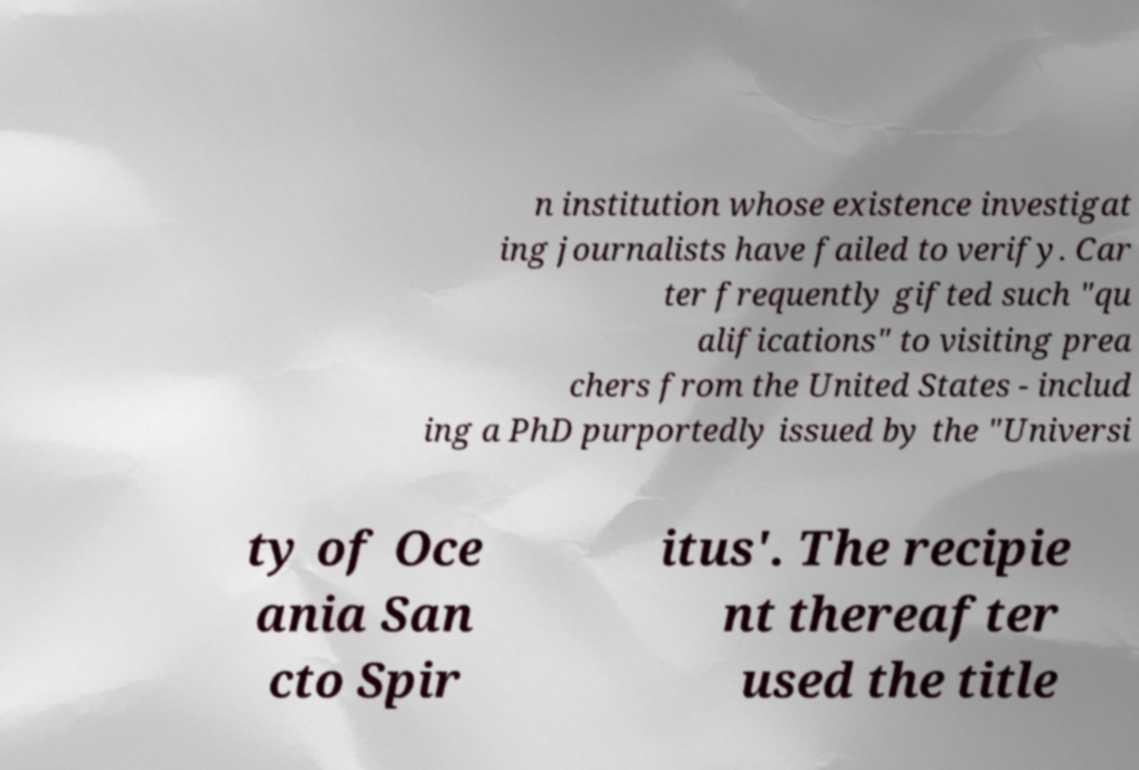Can you read and provide the text displayed in the image?This photo seems to have some interesting text. Can you extract and type it out for me? n institution whose existence investigat ing journalists have failed to verify. Car ter frequently gifted such "qu alifications" to visiting prea chers from the United States - includ ing a PhD purportedly issued by the "Universi ty of Oce ania San cto Spir itus'. The recipie nt thereafter used the title 